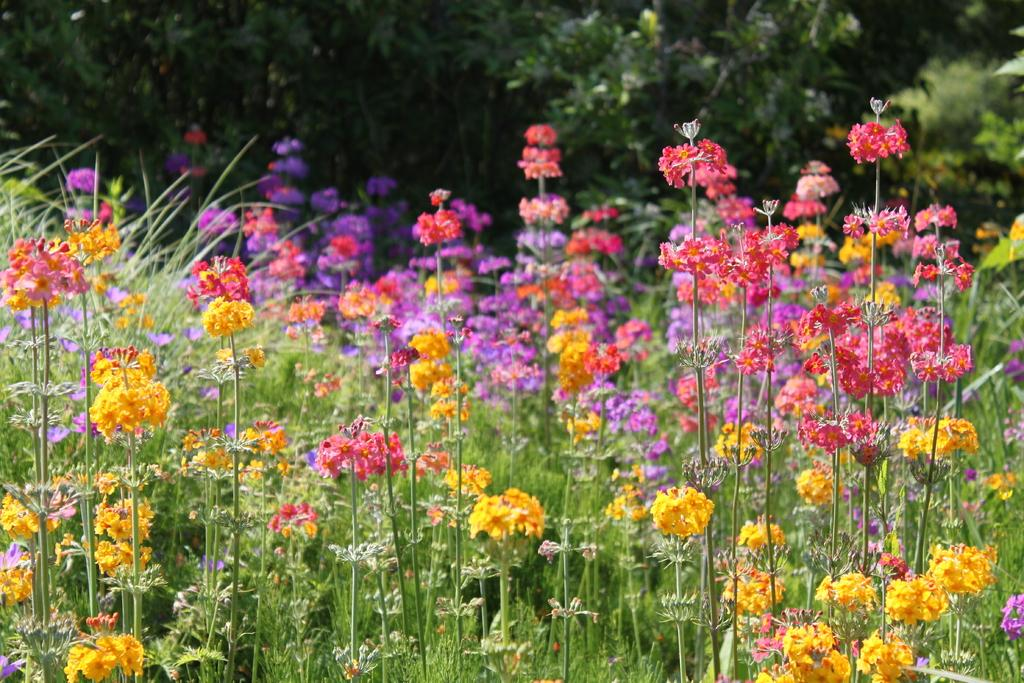What type of plants can be seen in the image? There are plants with flowers in the image. What can be seen in the background of the image? There are trees in the background of the image. What type of stocking is hanging on the tree in the image? There is no stocking present in the image; it features plants with flowers and trees in the background. 